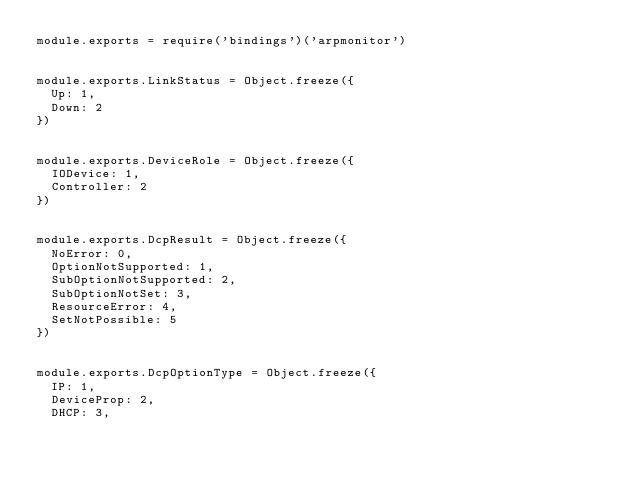Convert code to text. <code><loc_0><loc_0><loc_500><loc_500><_JavaScript_>module.exports = require('bindings')('arpmonitor')


module.exports.LinkStatus = Object.freeze({
  Up: 1,
  Down: 2
})


module.exports.DeviceRole = Object.freeze({
  IODevice: 1,
  Controller: 2
})


module.exports.DcpResult = Object.freeze({
  NoError: 0,
  OptionNotSupported: 1,
  SubOptionNotSupported: 2,
  SubOptionNotSet: 3,
  ResourceError: 4,
  SetNotPossible: 5  
})


module.exports.DcpOptionType = Object.freeze({
  IP: 1,
  DeviceProp: 2,
  DHCP: 3,</code> 